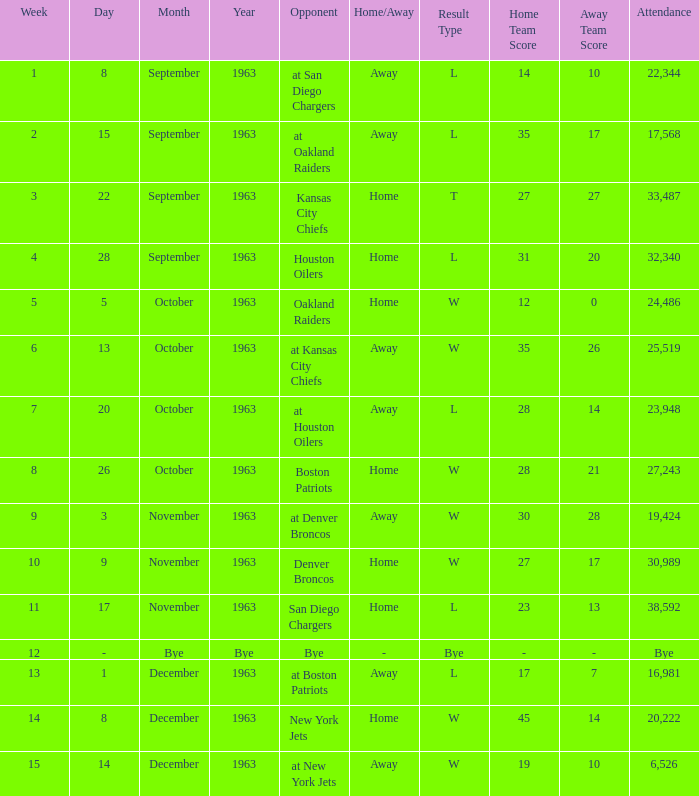Which Opponent has a Result of w 19–10? At new york jets. 